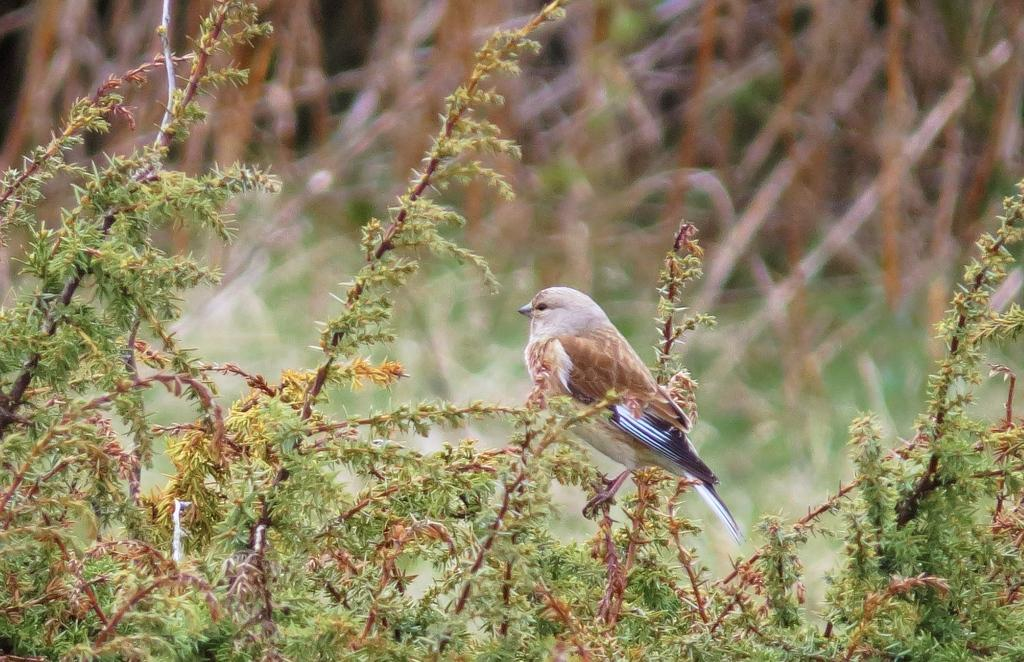What type of living organisms can be seen at the bottom of the image? There are plants at the bottom of the image. What animal is standing in the front of the image? There is a bird standing in the front of the image. Can you describe the background of the image? The background of the image is blurry. What type of stick is the bird using to perform an operation in the image? There is no stick or operation present in the image; it features a bird standing in front of plants. 